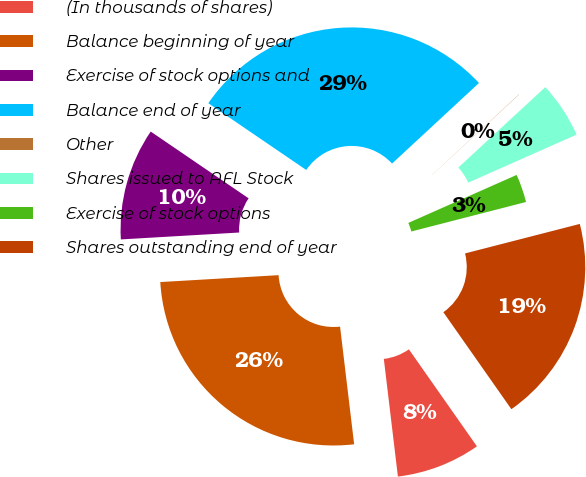Convert chart. <chart><loc_0><loc_0><loc_500><loc_500><pie_chart><fcel>(In thousands of shares)<fcel>Balance beginning of year<fcel>Exercise of stock options and<fcel>Balance end of year<fcel>Other<fcel>Shares issued to AFL Stock<fcel>Exercise of stock options<fcel>Shares outstanding end of year<nl><fcel>7.84%<fcel>25.97%<fcel>10.45%<fcel>28.58%<fcel>0.02%<fcel>5.24%<fcel>2.63%<fcel>19.27%<nl></chart> 